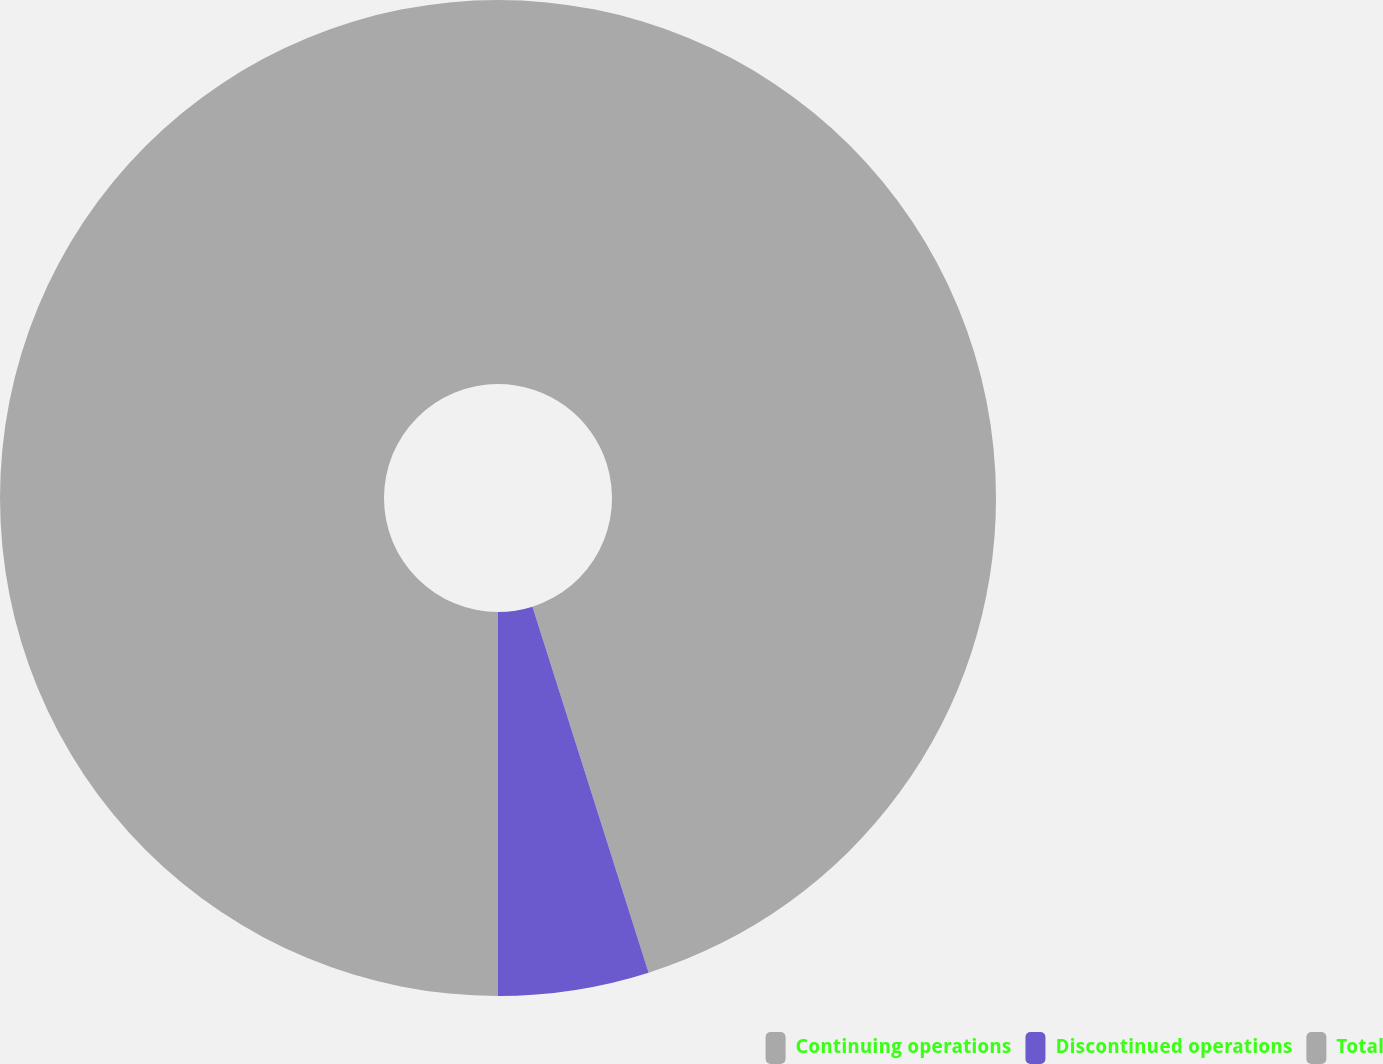Convert chart to OTSL. <chart><loc_0><loc_0><loc_500><loc_500><pie_chart><fcel>Continuing operations<fcel>Discontinued operations<fcel>Total<nl><fcel>45.11%<fcel>4.89%<fcel>50.0%<nl></chart> 